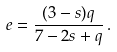<formula> <loc_0><loc_0><loc_500><loc_500>e = \frac { ( 3 - s ) q } { 7 - 2 s + q } \, .</formula> 